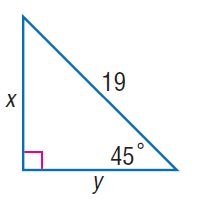Question: Find x.
Choices:
A. \frac { 17 \sqrt { 2 } } { 2 }
B. \frac { 19 \sqrt { 2 } } { 2 }
C. \frac { 21 \sqrt { 2 } } { 2 }
D. \frac { 23 \sqrt { 2 } } { 2 }
Answer with the letter. Answer: B Question: Find y.
Choices:
A. \frac { 17 \sqrt { 2 } } { 2 }
B. \frac { 19 \sqrt { 2 } } { 2 }
C. \frac { 21 \sqrt { 2 } } { 2 }
D. \frac { 23 \sqrt { 2 } } { 2 }
Answer with the letter. Answer: B 